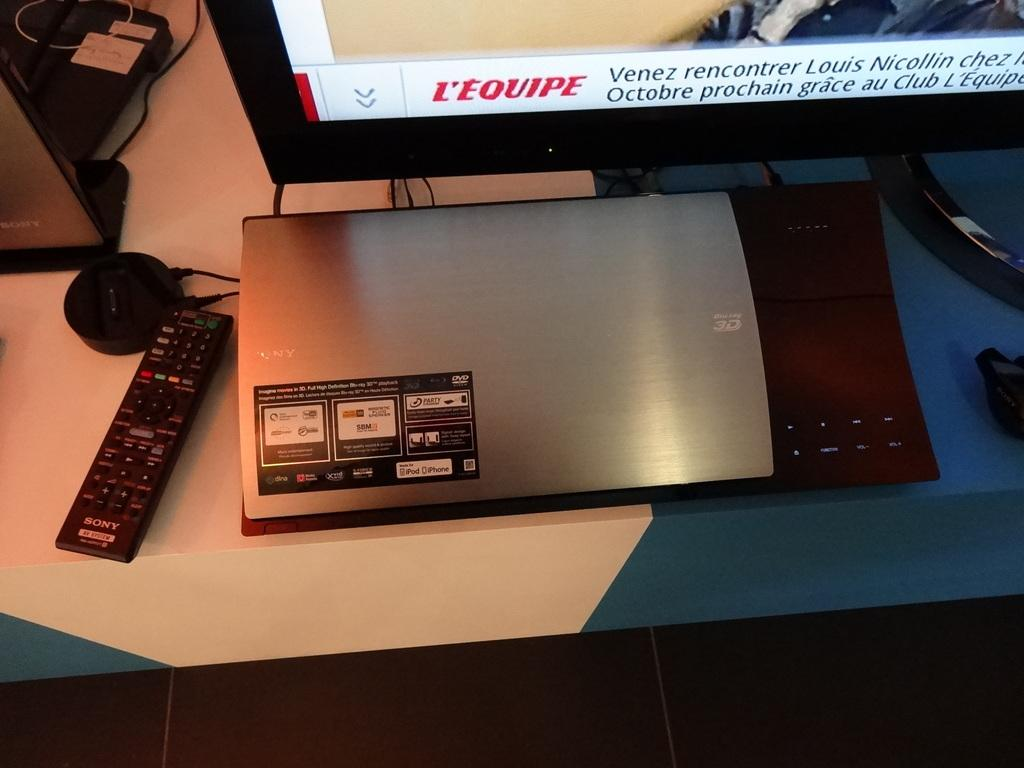Provide a one-sentence caption for the provided image. An electronic device in front of a tv and next to a  Sony brand remote. 